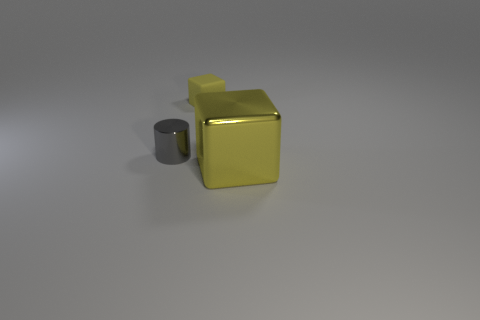Add 2 cylinders. How many objects exist? 5 Subtract all cubes. How many objects are left? 1 Subtract all big shiny objects. Subtract all rubber objects. How many objects are left? 1 Add 3 small gray things. How many small gray things are left? 4 Add 2 gray rubber cylinders. How many gray rubber cylinders exist? 2 Subtract 0 green spheres. How many objects are left? 3 